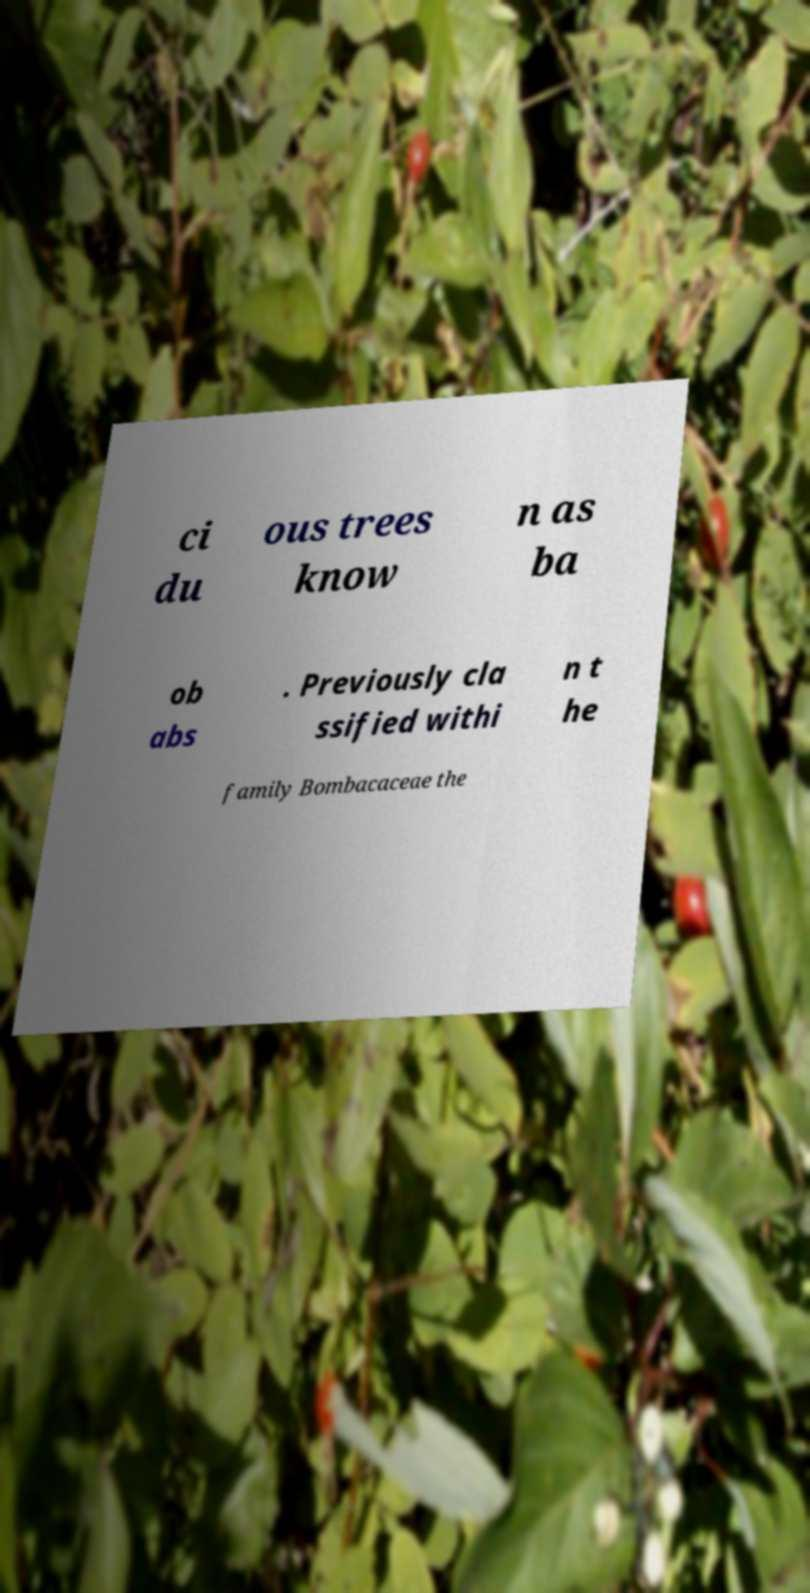Can you accurately transcribe the text from the provided image for me? ci du ous trees know n as ba ob abs . Previously cla ssified withi n t he family Bombacaceae the 